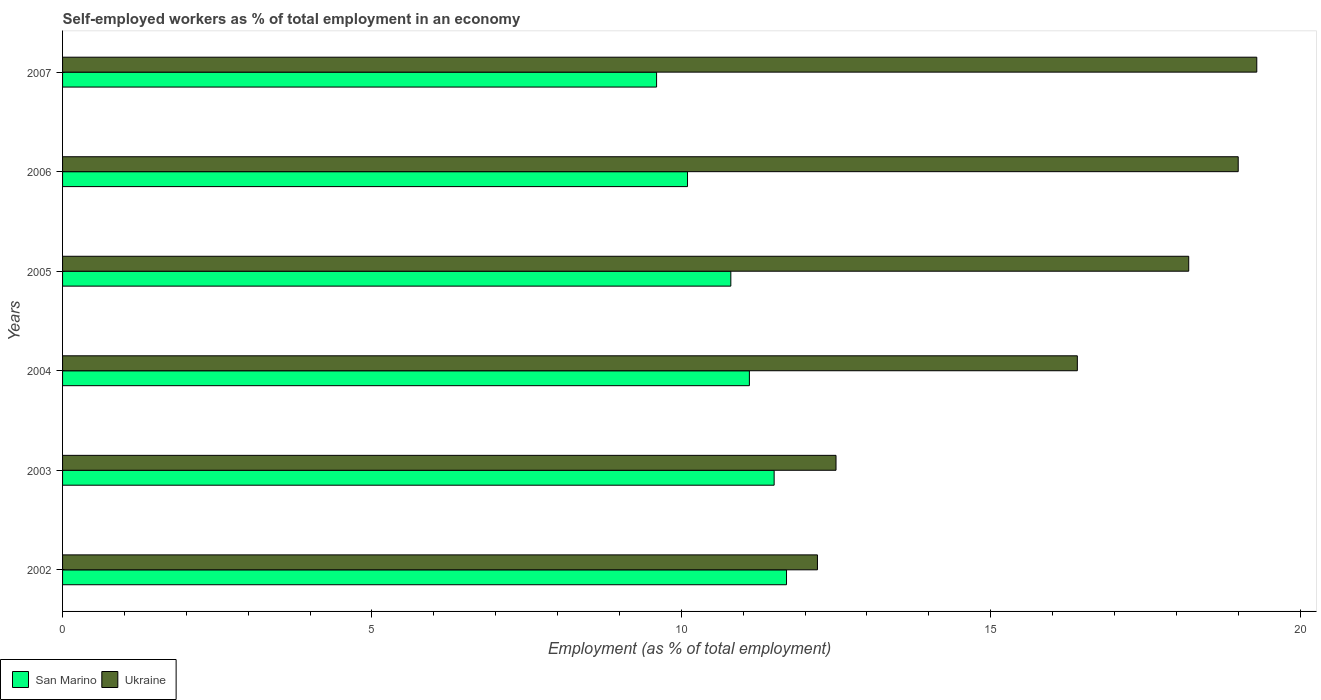How many different coloured bars are there?
Provide a succinct answer. 2. Are the number of bars per tick equal to the number of legend labels?
Provide a succinct answer. Yes. Are the number of bars on each tick of the Y-axis equal?
Provide a succinct answer. Yes. How many bars are there on the 3rd tick from the top?
Your answer should be very brief. 2. What is the label of the 1st group of bars from the top?
Keep it short and to the point. 2007. In how many cases, is the number of bars for a given year not equal to the number of legend labels?
Make the answer very short. 0. What is the percentage of self-employed workers in San Marino in 2003?
Offer a terse response. 11.5. Across all years, what is the maximum percentage of self-employed workers in Ukraine?
Your answer should be compact. 19.3. Across all years, what is the minimum percentage of self-employed workers in San Marino?
Offer a very short reply. 9.6. In which year was the percentage of self-employed workers in San Marino maximum?
Give a very brief answer. 2002. In which year was the percentage of self-employed workers in San Marino minimum?
Offer a very short reply. 2007. What is the total percentage of self-employed workers in San Marino in the graph?
Make the answer very short. 64.8. What is the difference between the percentage of self-employed workers in San Marino in 2004 and that in 2007?
Provide a short and direct response. 1.5. What is the difference between the percentage of self-employed workers in San Marino in 2005 and the percentage of self-employed workers in Ukraine in 2003?
Your response must be concise. -1.7. What is the average percentage of self-employed workers in San Marino per year?
Make the answer very short. 10.8. In the year 2004, what is the difference between the percentage of self-employed workers in San Marino and percentage of self-employed workers in Ukraine?
Keep it short and to the point. -5.3. In how many years, is the percentage of self-employed workers in Ukraine greater than 19 %?
Your answer should be compact. 1. What is the ratio of the percentage of self-employed workers in Ukraine in 2002 to that in 2004?
Your answer should be very brief. 0.74. Is the percentage of self-employed workers in San Marino in 2003 less than that in 2004?
Keep it short and to the point. No. What is the difference between the highest and the second highest percentage of self-employed workers in San Marino?
Ensure brevity in your answer.  0.2. What is the difference between the highest and the lowest percentage of self-employed workers in Ukraine?
Keep it short and to the point. 7.1. What does the 1st bar from the top in 2004 represents?
Provide a succinct answer. Ukraine. What does the 2nd bar from the bottom in 2007 represents?
Your response must be concise. Ukraine. How many bars are there?
Keep it short and to the point. 12. Are all the bars in the graph horizontal?
Ensure brevity in your answer.  Yes. How many years are there in the graph?
Offer a very short reply. 6. Are the values on the major ticks of X-axis written in scientific E-notation?
Ensure brevity in your answer.  No. Does the graph contain any zero values?
Make the answer very short. No. Does the graph contain grids?
Provide a succinct answer. No. How many legend labels are there?
Offer a very short reply. 2. How are the legend labels stacked?
Ensure brevity in your answer.  Horizontal. What is the title of the graph?
Ensure brevity in your answer.  Self-employed workers as % of total employment in an economy. Does "Lebanon" appear as one of the legend labels in the graph?
Keep it short and to the point. No. What is the label or title of the X-axis?
Provide a short and direct response. Employment (as % of total employment). What is the label or title of the Y-axis?
Keep it short and to the point. Years. What is the Employment (as % of total employment) in San Marino in 2002?
Offer a very short reply. 11.7. What is the Employment (as % of total employment) in Ukraine in 2002?
Your answer should be very brief. 12.2. What is the Employment (as % of total employment) of San Marino in 2003?
Give a very brief answer. 11.5. What is the Employment (as % of total employment) of San Marino in 2004?
Keep it short and to the point. 11.1. What is the Employment (as % of total employment) of Ukraine in 2004?
Keep it short and to the point. 16.4. What is the Employment (as % of total employment) in San Marino in 2005?
Provide a short and direct response. 10.8. What is the Employment (as % of total employment) in Ukraine in 2005?
Your answer should be very brief. 18.2. What is the Employment (as % of total employment) in San Marino in 2006?
Give a very brief answer. 10.1. What is the Employment (as % of total employment) in Ukraine in 2006?
Provide a succinct answer. 19. What is the Employment (as % of total employment) of San Marino in 2007?
Make the answer very short. 9.6. What is the Employment (as % of total employment) in Ukraine in 2007?
Your response must be concise. 19.3. Across all years, what is the maximum Employment (as % of total employment) in San Marino?
Provide a short and direct response. 11.7. Across all years, what is the maximum Employment (as % of total employment) of Ukraine?
Ensure brevity in your answer.  19.3. Across all years, what is the minimum Employment (as % of total employment) of San Marino?
Offer a terse response. 9.6. Across all years, what is the minimum Employment (as % of total employment) in Ukraine?
Your response must be concise. 12.2. What is the total Employment (as % of total employment) in San Marino in the graph?
Your response must be concise. 64.8. What is the total Employment (as % of total employment) in Ukraine in the graph?
Make the answer very short. 97.6. What is the difference between the Employment (as % of total employment) in Ukraine in 2002 and that in 2004?
Your answer should be very brief. -4.2. What is the difference between the Employment (as % of total employment) of Ukraine in 2002 and that in 2005?
Your answer should be compact. -6. What is the difference between the Employment (as % of total employment) of San Marino in 2002 and that in 2006?
Make the answer very short. 1.6. What is the difference between the Employment (as % of total employment) in Ukraine in 2002 and that in 2006?
Your response must be concise. -6.8. What is the difference between the Employment (as % of total employment) in San Marino in 2003 and that in 2004?
Your response must be concise. 0.4. What is the difference between the Employment (as % of total employment) in Ukraine in 2003 and that in 2004?
Provide a short and direct response. -3.9. What is the difference between the Employment (as % of total employment) in San Marino in 2003 and that in 2006?
Your response must be concise. 1.4. What is the difference between the Employment (as % of total employment) in San Marino in 2003 and that in 2007?
Your answer should be very brief. 1.9. What is the difference between the Employment (as % of total employment) in Ukraine in 2004 and that in 2006?
Your answer should be very brief. -2.6. What is the difference between the Employment (as % of total employment) of San Marino in 2005 and that in 2006?
Your answer should be very brief. 0.7. What is the difference between the Employment (as % of total employment) of San Marino in 2005 and that in 2007?
Your answer should be compact. 1.2. What is the difference between the Employment (as % of total employment) of Ukraine in 2006 and that in 2007?
Offer a terse response. -0.3. What is the difference between the Employment (as % of total employment) in San Marino in 2002 and the Employment (as % of total employment) in Ukraine in 2004?
Provide a short and direct response. -4.7. What is the difference between the Employment (as % of total employment) of San Marino in 2002 and the Employment (as % of total employment) of Ukraine in 2005?
Ensure brevity in your answer.  -6.5. What is the difference between the Employment (as % of total employment) of San Marino in 2002 and the Employment (as % of total employment) of Ukraine in 2007?
Provide a succinct answer. -7.6. What is the difference between the Employment (as % of total employment) of San Marino in 2003 and the Employment (as % of total employment) of Ukraine in 2007?
Your answer should be compact. -7.8. What is the difference between the Employment (as % of total employment) of San Marino in 2004 and the Employment (as % of total employment) of Ukraine in 2007?
Your answer should be very brief. -8.2. What is the difference between the Employment (as % of total employment) of San Marino in 2005 and the Employment (as % of total employment) of Ukraine in 2007?
Make the answer very short. -8.5. What is the average Employment (as % of total employment) of San Marino per year?
Provide a short and direct response. 10.8. What is the average Employment (as % of total employment) in Ukraine per year?
Your answer should be very brief. 16.27. In the year 2002, what is the difference between the Employment (as % of total employment) of San Marino and Employment (as % of total employment) of Ukraine?
Keep it short and to the point. -0.5. In the year 2003, what is the difference between the Employment (as % of total employment) in San Marino and Employment (as % of total employment) in Ukraine?
Provide a short and direct response. -1. In the year 2004, what is the difference between the Employment (as % of total employment) in San Marino and Employment (as % of total employment) in Ukraine?
Your answer should be compact. -5.3. What is the ratio of the Employment (as % of total employment) in San Marino in 2002 to that in 2003?
Offer a very short reply. 1.02. What is the ratio of the Employment (as % of total employment) of Ukraine in 2002 to that in 2003?
Your response must be concise. 0.98. What is the ratio of the Employment (as % of total employment) of San Marino in 2002 to that in 2004?
Your answer should be compact. 1.05. What is the ratio of the Employment (as % of total employment) of Ukraine in 2002 to that in 2004?
Offer a terse response. 0.74. What is the ratio of the Employment (as % of total employment) in Ukraine in 2002 to that in 2005?
Offer a very short reply. 0.67. What is the ratio of the Employment (as % of total employment) of San Marino in 2002 to that in 2006?
Provide a succinct answer. 1.16. What is the ratio of the Employment (as % of total employment) of Ukraine in 2002 to that in 2006?
Offer a very short reply. 0.64. What is the ratio of the Employment (as % of total employment) in San Marino in 2002 to that in 2007?
Keep it short and to the point. 1.22. What is the ratio of the Employment (as % of total employment) in Ukraine in 2002 to that in 2007?
Keep it short and to the point. 0.63. What is the ratio of the Employment (as % of total employment) in San Marino in 2003 to that in 2004?
Your response must be concise. 1.04. What is the ratio of the Employment (as % of total employment) in Ukraine in 2003 to that in 2004?
Offer a terse response. 0.76. What is the ratio of the Employment (as % of total employment) in San Marino in 2003 to that in 2005?
Ensure brevity in your answer.  1.06. What is the ratio of the Employment (as % of total employment) of Ukraine in 2003 to that in 2005?
Give a very brief answer. 0.69. What is the ratio of the Employment (as % of total employment) of San Marino in 2003 to that in 2006?
Your answer should be very brief. 1.14. What is the ratio of the Employment (as % of total employment) of Ukraine in 2003 to that in 2006?
Your response must be concise. 0.66. What is the ratio of the Employment (as % of total employment) of San Marino in 2003 to that in 2007?
Ensure brevity in your answer.  1.2. What is the ratio of the Employment (as % of total employment) in Ukraine in 2003 to that in 2007?
Your response must be concise. 0.65. What is the ratio of the Employment (as % of total employment) in San Marino in 2004 to that in 2005?
Keep it short and to the point. 1.03. What is the ratio of the Employment (as % of total employment) in Ukraine in 2004 to that in 2005?
Keep it short and to the point. 0.9. What is the ratio of the Employment (as % of total employment) in San Marino in 2004 to that in 2006?
Your answer should be compact. 1.1. What is the ratio of the Employment (as % of total employment) of Ukraine in 2004 to that in 2006?
Provide a succinct answer. 0.86. What is the ratio of the Employment (as % of total employment) of San Marino in 2004 to that in 2007?
Your answer should be compact. 1.16. What is the ratio of the Employment (as % of total employment) in Ukraine in 2004 to that in 2007?
Keep it short and to the point. 0.85. What is the ratio of the Employment (as % of total employment) in San Marino in 2005 to that in 2006?
Offer a very short reply. 1.07. What is the ratio of the Employment (as % of total employment) of Ukraine in 2005 to that in 2006?
Make the answer very short. 0.96. What is the ratio of the Employment (as % of total employment) in San Marino in 2005 to that in 2007?
Provide a short and direct response. 1.12. What is the ratio of the Employment (as % of total employment) in Ukraine in 2005 to that in 2007?
Ensure brevity in your answer.  0.94. What is the ratio of the Employment (as % of total employment) of San Marino in 2006 to that in 2007?
Offer a very short reply. 1.05. What is the ratio of the Employment (as % of total employment) in Ukraine in 2006 to that in 2007?
Ensure brevity in your answer.  0.98. What is the difference between the highest and the second highest Employment (as % of total employment) in San Marino?
Ensure brevity in your answer.  0.2. What is the difference between the highest and the second highest Employment (as % of total employment) in Ukraine?
Provide a succinct answer. 0.3. What is the difference between the highest and the lowest Employment (as % of total employment) in San Marino?
Your response must be concise. 2.1. What is the difference between the highest and the lowest Employment (as % of total employment) of Ukraine?
Your answer should be very brief. 7.1. 